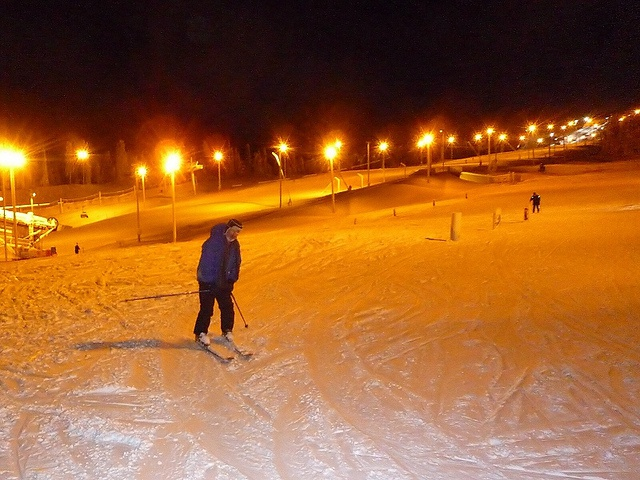Describe the objects in this image and their specific colors. I can see people in black, maroon, and purple tones, skis in black, gray, tan, maroon, and brown tones, people in black, maroon, orange, and brown tones, and people in maroon, brown, and black tones in this image. 